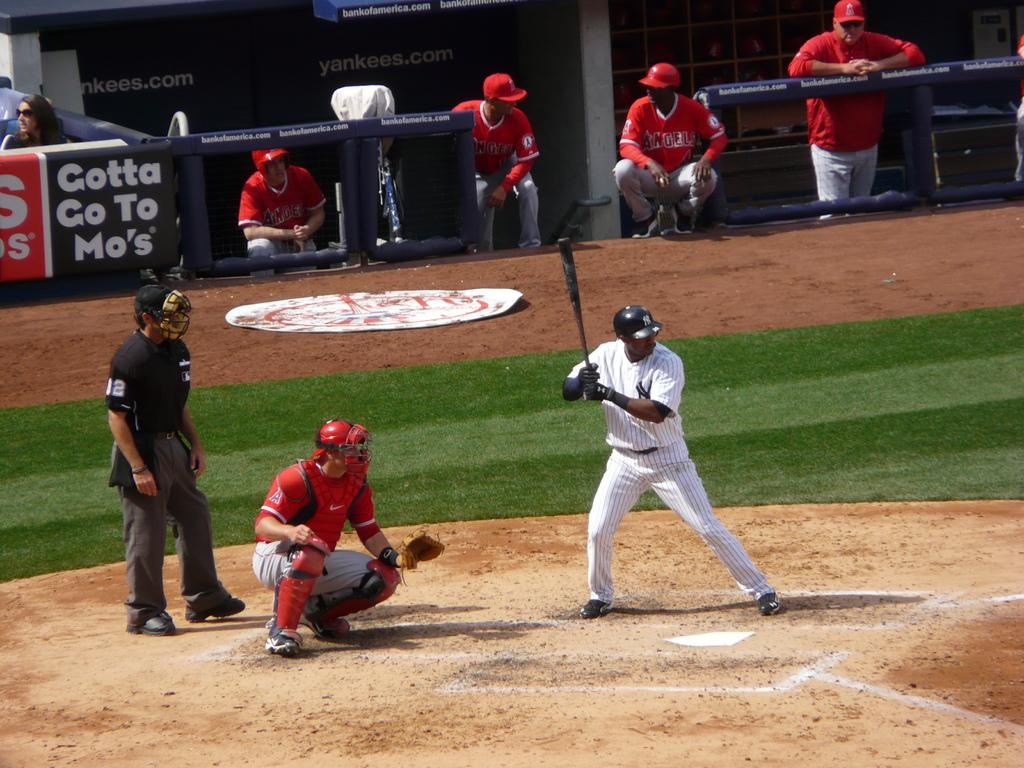<image>
Share a concise interpretation of the image provided. a player with a white jersey batting with a Gotta go to Mos' sign behind 